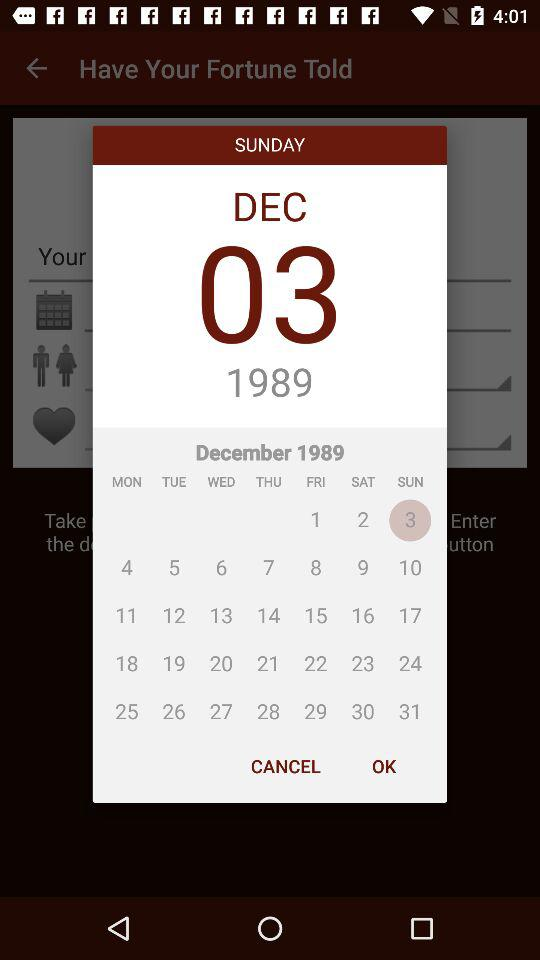What is the day that is mentioned? The mentioned day is Sunday. 